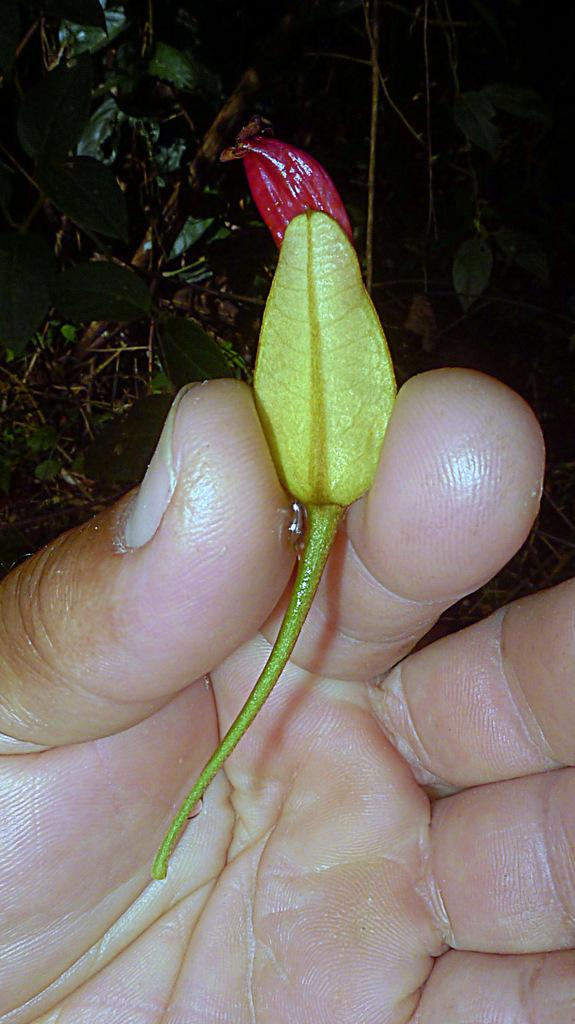What body part is visible in the image? Human fingers are visible in the image. What is the fingers holding in the image? A bud flower is being held by the fingers. What type of plant material is present in the image? Leaves are present in the image. What type of powder can be seen on the fingers in the image? There is no powder visible on the fingers in the image. 